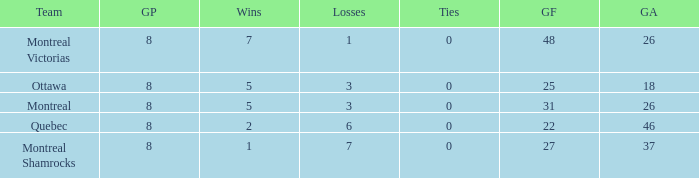For teams with fewer than 5 wins, goals against over 37, and fewer than 8 games played, what is the average number of ties? None. 